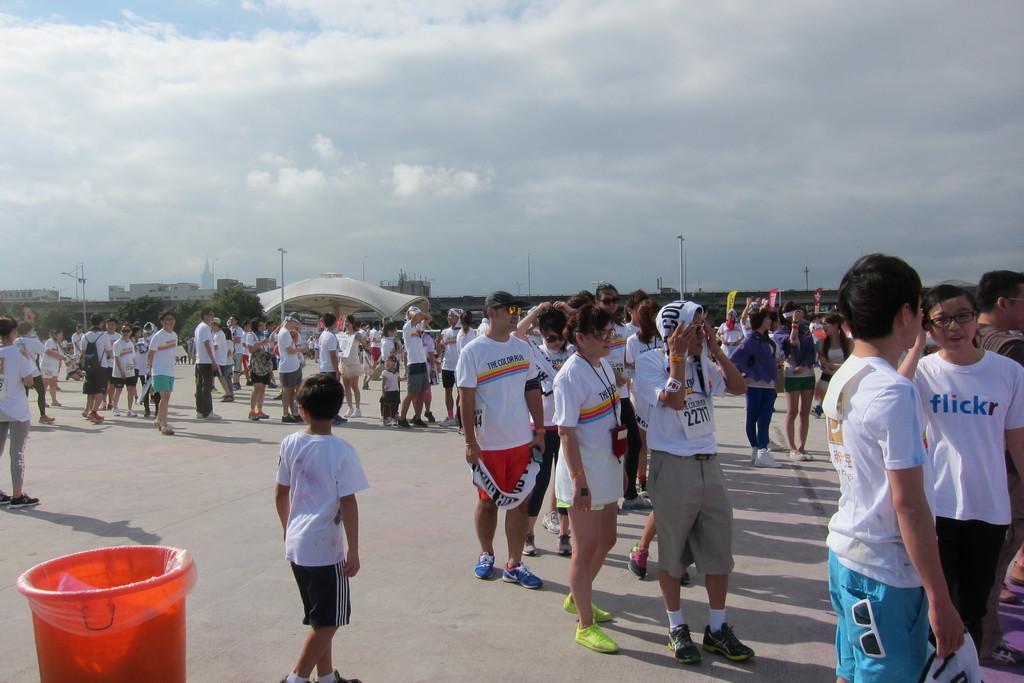Could you give a brief overview of what you see in this image? Here in this picture we can see number of people standing on the road here and there and most of them are wearing white colored t shirts on them and on the left side we can see a red color dustbin present over there and in the far we can see an arch and we can see trees and plants present over there and we can see light posts here and there and we can also see buildings in the far and we can see the sky is full of clouds over there. 